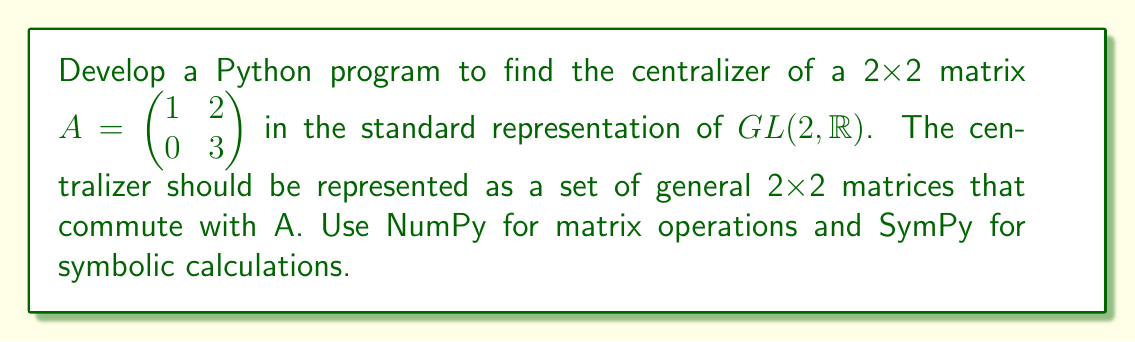Can you solve this math problem? 1. Import required libraries:
   ```python
   import numpy as np
   from sympy import symbols, Eq, solve
   ```

2. Define the given matrix A:
   ```python
   A = np.array([[1, 2], [0, 3]])
   ```

3. Create a general 2x2 matrix X with symbolic entries:
   ```python
   a, b, c, d = symbols('a b c d')
   X = np.array([[a, b], [c, d]])
   ```

4. Calculate the matrix products AX and XA:
   ```python
   AX = np.dot(A, X)
   XA = np.dot(X, A)
   ```

5. Set up the equation AX = XA:
   ```python
   equations = []
   for i in range(2):
       for j in range(2):
           equations.append(Eq(AX[i,j], XA[i,j]))
   ```

6. Solve the system of equations:
   ```python
   solution = solve(equations)
   ```

7. Interpret the solution:
   The solution will give us the conditions for the entries of X that make it commute with A. In this case, we get:
   $c = 0$, $b = 2(a-d)/3$

8. Express the centralizer as a set of matrices:
   The centralizer of A is the set of all matrices X of the form:
   $$X = \begin{pmatrix} a & \frac{2(a-d)}{3} \\ 0 & d \end{pmatrix}$$
   where $a$ and $d$ are free variables in $\mathbb{R}$.

9. Return the result as a string representation of the general matrix form:
   ```python
   result = "{{a, (2/3)*(a-d)}, {0, d}}"
   return result
   ```
Answer: "{{a, (2/3)*(a-d)}, {0, d}}" 